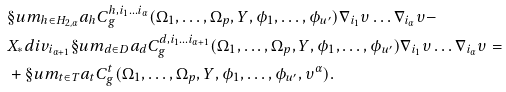<formula> <loc_0><loc_0><loc_500><loc_500>& \S u m _ { h \in H _ { 2 , \alpha } } a _ { h } C ^ { h , i _ { 1 } \dots i _ { \alpha } } _ { g } ( \Omega _ { 1 } , \dots , \Omega _ { p } , Y , \phi _ { 1 } , \dots , \phi _ { u ^ { \prime } } ) \nabla _ { i _ { 1 } } \upsilon \dots \nabla _ { i _ { \alpha } } \upsilon - \\ & X _ { * } d i v _ { i _ { \alpha + 1 } } \S u m _ { d \in D } a _ { d } C ^ { d , i _ { 1 } \dots i _ { \alpha + 1 } } _ { g } ( \Omega _ { 1 } , \dots , \Omega _ { p } , Y , \phi _ { 1 } , \dots , \phi _ { u ^ { \prime } } ) \nabla _ { i _ { 1 } } \upsilon \dots \nabla _ { i _ { \alpha } } \upsilon = \\ & + \S u m _ { t \in T } a _ { t } C ^ { t } _ { g } ( \Omega _ { 1 } , \dots , \Omega _ { p } , Y , \phi _ { 1 } , \dots , \phi _ { u ^ { \prime } } , \upsilon ^ { \alpha } ) .</formula> 